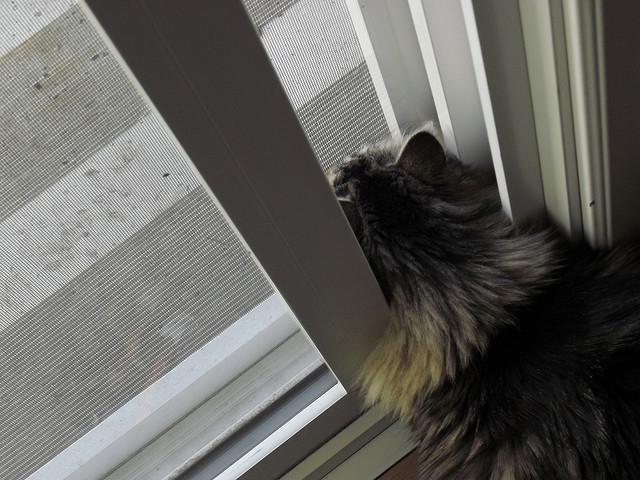Dog or cat?
Be succinct. Cat. What color is the cat in the window sill?
Write a very short answer. Brown. Where is the photographer standing?
Write a very short answer. Behind cat. What type of fur does the cat have?
Answer briefly. Long. What kind of animal is shown?
Quick response, please. Cat. Where the cat's head?
Write a very short answer. Window. What kind of animal is this?
Concise answer only. Cat. What is the cat looking out of?
Answer briefly. Door. 